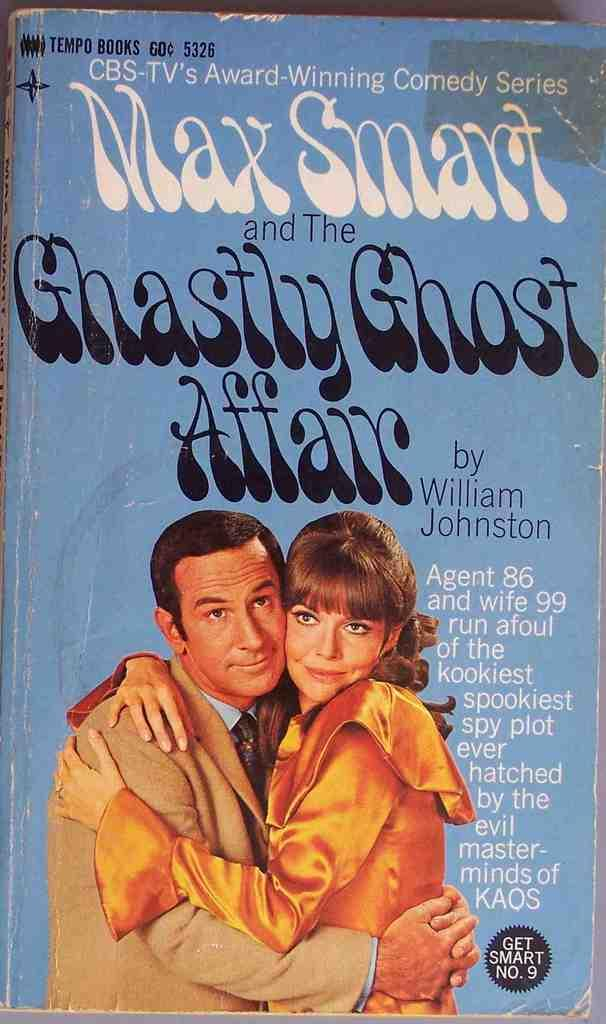Provide a one-sentence caption for the provided image. A paperback book brings the Get Smart comedy series to the page. 